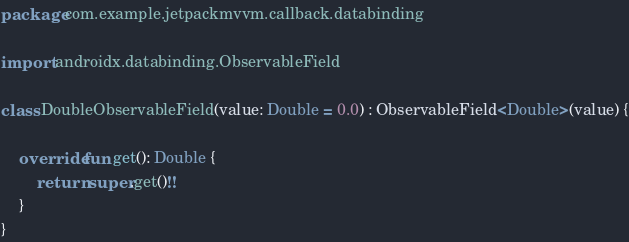Convert code to text. <code><loc_0><loc_0><loc_500><loc_500><_Kotlin_>package com.example.jetpackmvvm.callback.databinding

import androidx.databinding.ObservableField

class DoubleObservableField(value: Double = 0.0) : ObservableField<Double>(value) {

    override fun get(): Double {
        return super.get()!!
    }
}</code> 